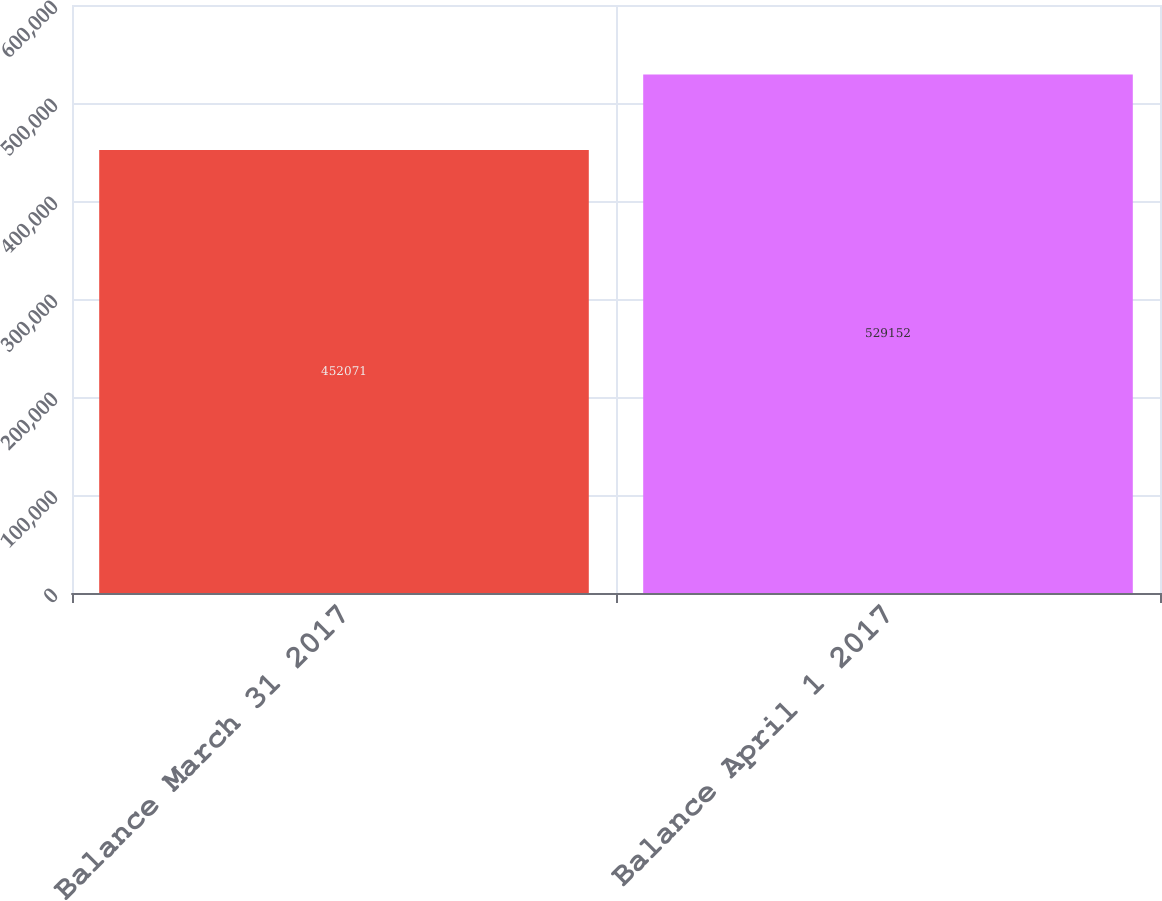<chart> <loc_0><loc_0><loc_500><loc_500><bar_chart><fcel>Balance March 31 2017<fcel>Balance April 1 2017<nl><fcel>452071<fcel>529152<nl></chart> 